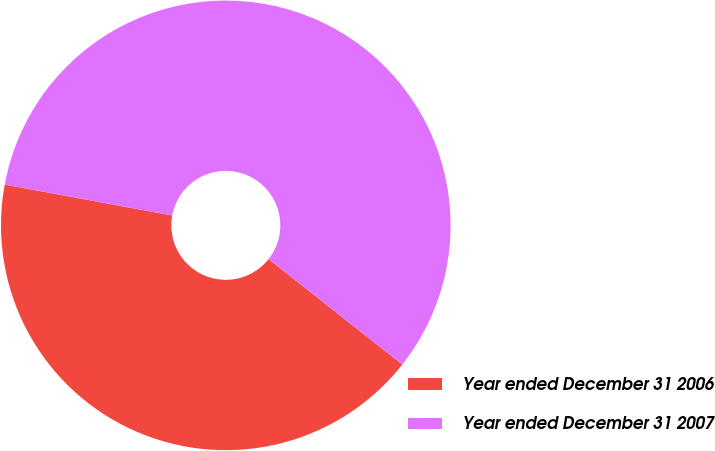<chart> <loc_0><loc_0><loc_500><loc_500><pie_chart><fcel>Year ended December 31 2006<fcel>Year ended December 31 2007<nl><fcel>42.28%<fcel>57.72%<nl></chart> 